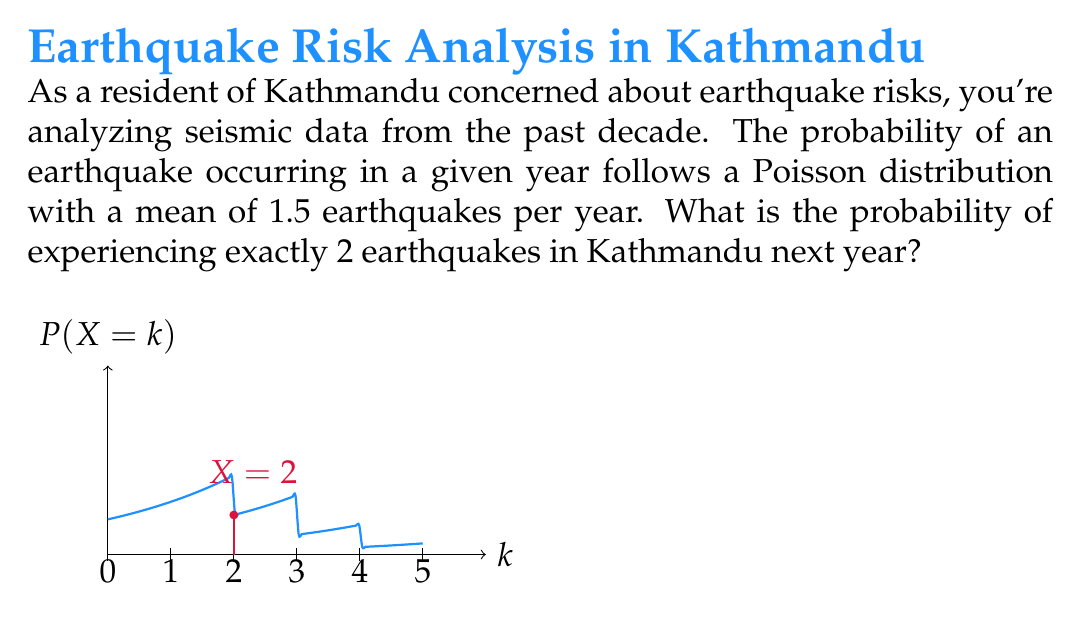Teach me how to tackle this problem. Let's approach this step-by-step:

1) The Poisson distribution is given by the formula:

   $$P(X = k) = \frac{e^{-\lambda}\lambda^k}{k!}$$

   where:
   - $\lambda$ is the average number of events in the interval
   - $k$ is the number of events we're calculating the probability for
   - $e$ is Euler's number (approximately 2.71828)

2) In this case:
   - $\lambda = 1.5$ (mean of 1.5 earthquakes per year)
   - $k = 2$ (we're calculating the probability of exactly 2 earthquakes)

3) Let's substitute these values into the formula:

   $$P(X = 2) = \frac{e^{-1.5}(1.5)^2}{2!}$$

4) Now, let's calculate step by step:
   - $e^{-1.5} \approx 0.22313$
   - $(1.5)^2 = 2.25$
   - $2! = 2 \times 1 = 2$

5) Substituting these values:

   $$P(X = 2) = \frac{0.22313 \times 2.25}{2} = 0.25102$$

6) Therefore, the probability of experiencing exactly 2 earthquakes in Kathmandu next year is approximately 0.25102 or 25.102%.
Answer: 0.25102 